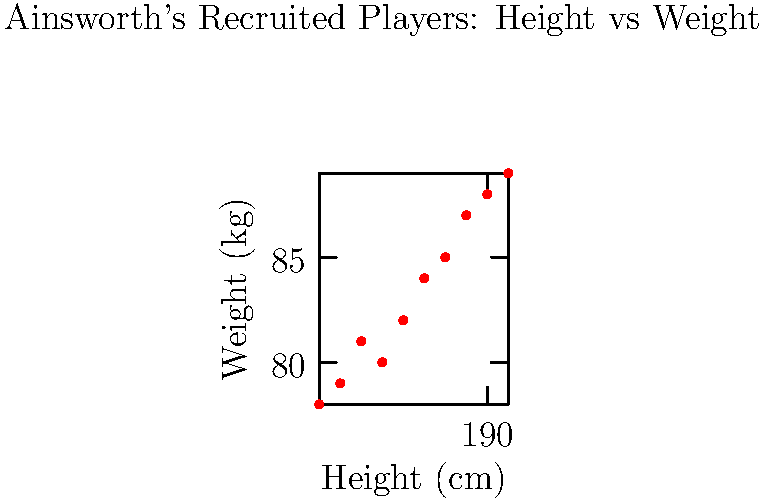Based on the scatter plot of physical attributes for players recruited by Gareth Ainsworth, what can be inferred about his preference for player build? Consider the relationship between height and weight shown in the data. To analyze Gareth Ainsworth's preference for player build, we need to examine the scatter plot carefully:

1. Height range: The heights of recruited players range from approximately 182 cm to 191 cm.

2. Weight range: The weights of recruited players range from about 78 kg to 89 kg.

3. Correlation: There appears to be a positive correlation between height and weight, which is expected in athletic populations.

4. Clustering: The data points are relatively clustered, suggesting Ainsworth has a specific "type" of player he prefers.

5. Average build: The center of the cluster is around 186-187 cm in height and 83-84 kg in weight, indicating a preference for tall, well-built players.

6. Outliers: There are no significant outliers, reinforcing the idea of a consistent recruitment strategy.

7. Physical demands: The preference for taller, heavier players suggests Ainsworth values physical presence and strength in his team.

8. Playing style: This data aligns with Ainsworth's known philosophy of direct, physical football that requires robust players.

Given these observations, we can infer that Ainsworth prefers recruiting physically imposing players who are both tall and well-built, likely to suit his direct and aggressive playing style.
Answer: Preference for tall, well-built players to suit a direct, physical playing style. 